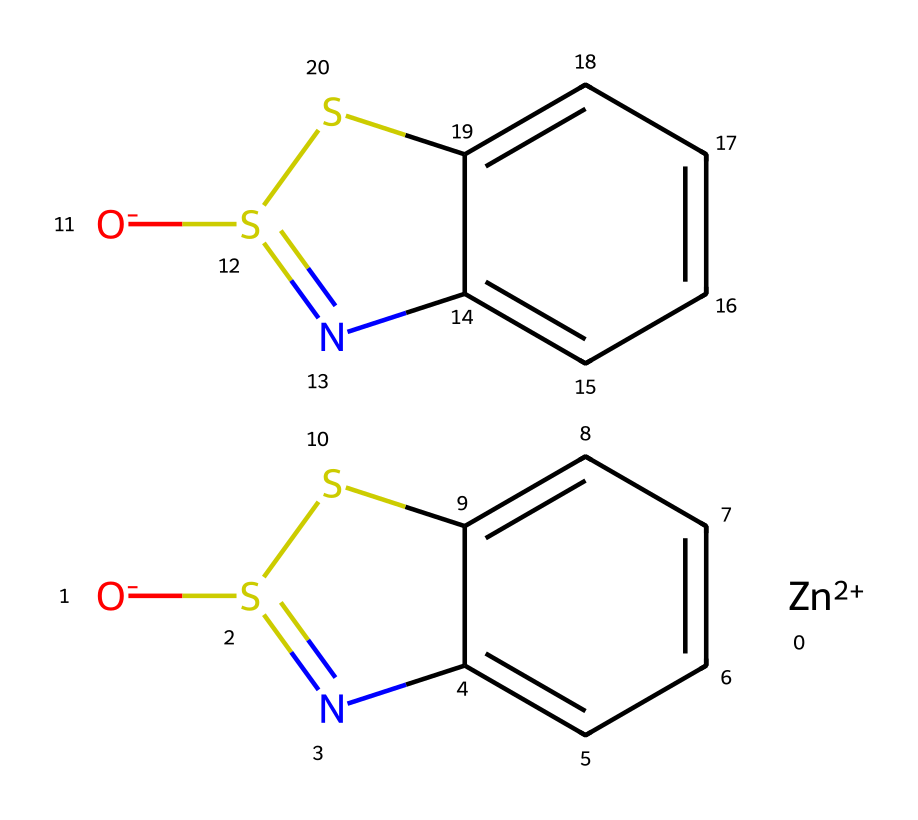What is the central metal ion in this compound? The chemical structure features a zinc atom denoted as [Zn+2], which represents the central metal ion in this coordination compound.
Answer: zinc How many sulfur atoms are present in this compound? By analyzing the structure, there are two distinct sulfur atoms connected to the nitrogen and carbon atoms, as indicated by the two [O-]S1 groups.
Answer: two What is the oxidation state of zinc in this compound? The notation [Zn+2] indicates that the zinc atom has a +2 oxidation state, as the plus sign denotes the charge on the ion.
Answer: +2 How many nitrogen atoms are there in the structure? The structure contains two nitrogen atoms, as indicated by the presence of the "N" in the SMILES representation, which shows that each pyrithione unit contributes one nitrogen.
Answer: two What type of compound is zinc pyrithione classified as? Zinc pyrithione is classified as a coordination compound due to the coordination of the zinc ion with the pyrithione ligands, which contain functional groups capable of forming bonds with the metal.
Answer: coordination compound Which part of the molecule provides its antifungal properties? The pyrithione moiety contains a thiol group (the sulfur compounds), which is known to impart antifungal activity, linking it to the structure of zinc pyrithione.
Answer: pyrithione moiety 